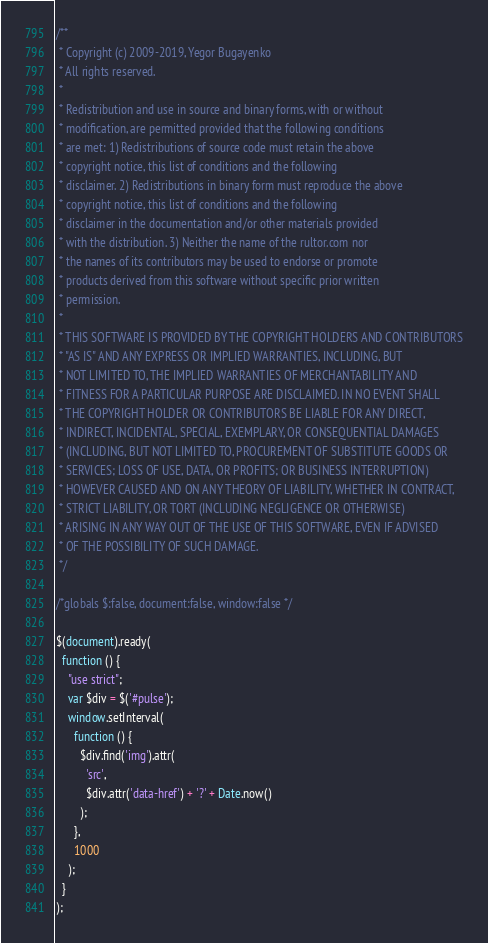<code> <loc_0><loc_0><loc_500><loc_500><_JavaScript_>/**
 * Copyright (c) 2009-2019, Yegor Bugayenko
 * All rights reserved.
 *
 * Redistribution and use in source and binary forms, with or without
 * modification, are permitted provided that the following conditions
 * are met: 1) Redistributions of source code must retain the above
 * copyright notice, this list of conditions and the following
 * disclaimer. 2) Redistributions in binary form must reproduce the above
 * copyright notice, this list of conditions and the following
 * disclaimer in the documentation and/or other materials provided
 * with the distribution. 3) Neither the name of the rultor.com nor
 * the names of its contributors may be used to endorse or promote
 * products derived from this software without specific prior written
 * permission.
 *
 * THIS SOFTWARE IS PROVIDED BY THE COPYRIGHT HOLDERS AND CONTRIBUTORS
 * "AS IS" AND ANY EXPRESS OR IMPLIED WARRANTIES, INCLUDING, BUT
 * NOT LIMITED TO, THE IMPLIED WARRANTIES OF MERCHANTABILITY AND
 * FITNESS FOR A PARTICULAR PURPOSE ARE DISCLAIMED. IN NO EVENT SHALL
 * THE COPYRIGHT HOLDER OR CONTRIBUTORS BE LIABLE FOR ANY DIRECT,
 * INDIRECT, INCIDENTAL, SPECIAL, EXEMPLARY, OR CONSEQUENTIAL DAMAGES
 * (INCLUDING, BUT NOT LIMITED TO, PROCUREMENT OF SUBSTITUTE GOODS OR
 * SERVICES; LOSS OF USE, DATA, OR PROFITS; OR BUSINESS INTERRUPTION)
 * HOWEVER CAUSED AND ON ANY THEORY OF LIABILITY, WHETHER IN CONTRACT,
 * STRICT LIABILITY, OR TORT (INCLUDING NEGLIGENCE OR OTHERWISE)
 * ARISING IN ANY WAY OUT OF THE USE OF THIS SOFTWARE, EVEN IF ADVISED
 * OF THE POSSIBILITY OF SUCH DAMAGE.
 */

/*globals $:false, document:false, window:false */

$(document).ready(
  function () {
    "use strict";
    var $div = $('#pulse');
    window.setInterval(
      function () {
        $div.find('img').attr(
          'src',
          $div.attr('data-href') + '?' + Date.now()
        );
      },
      1000
    );
  }
);
</code> 